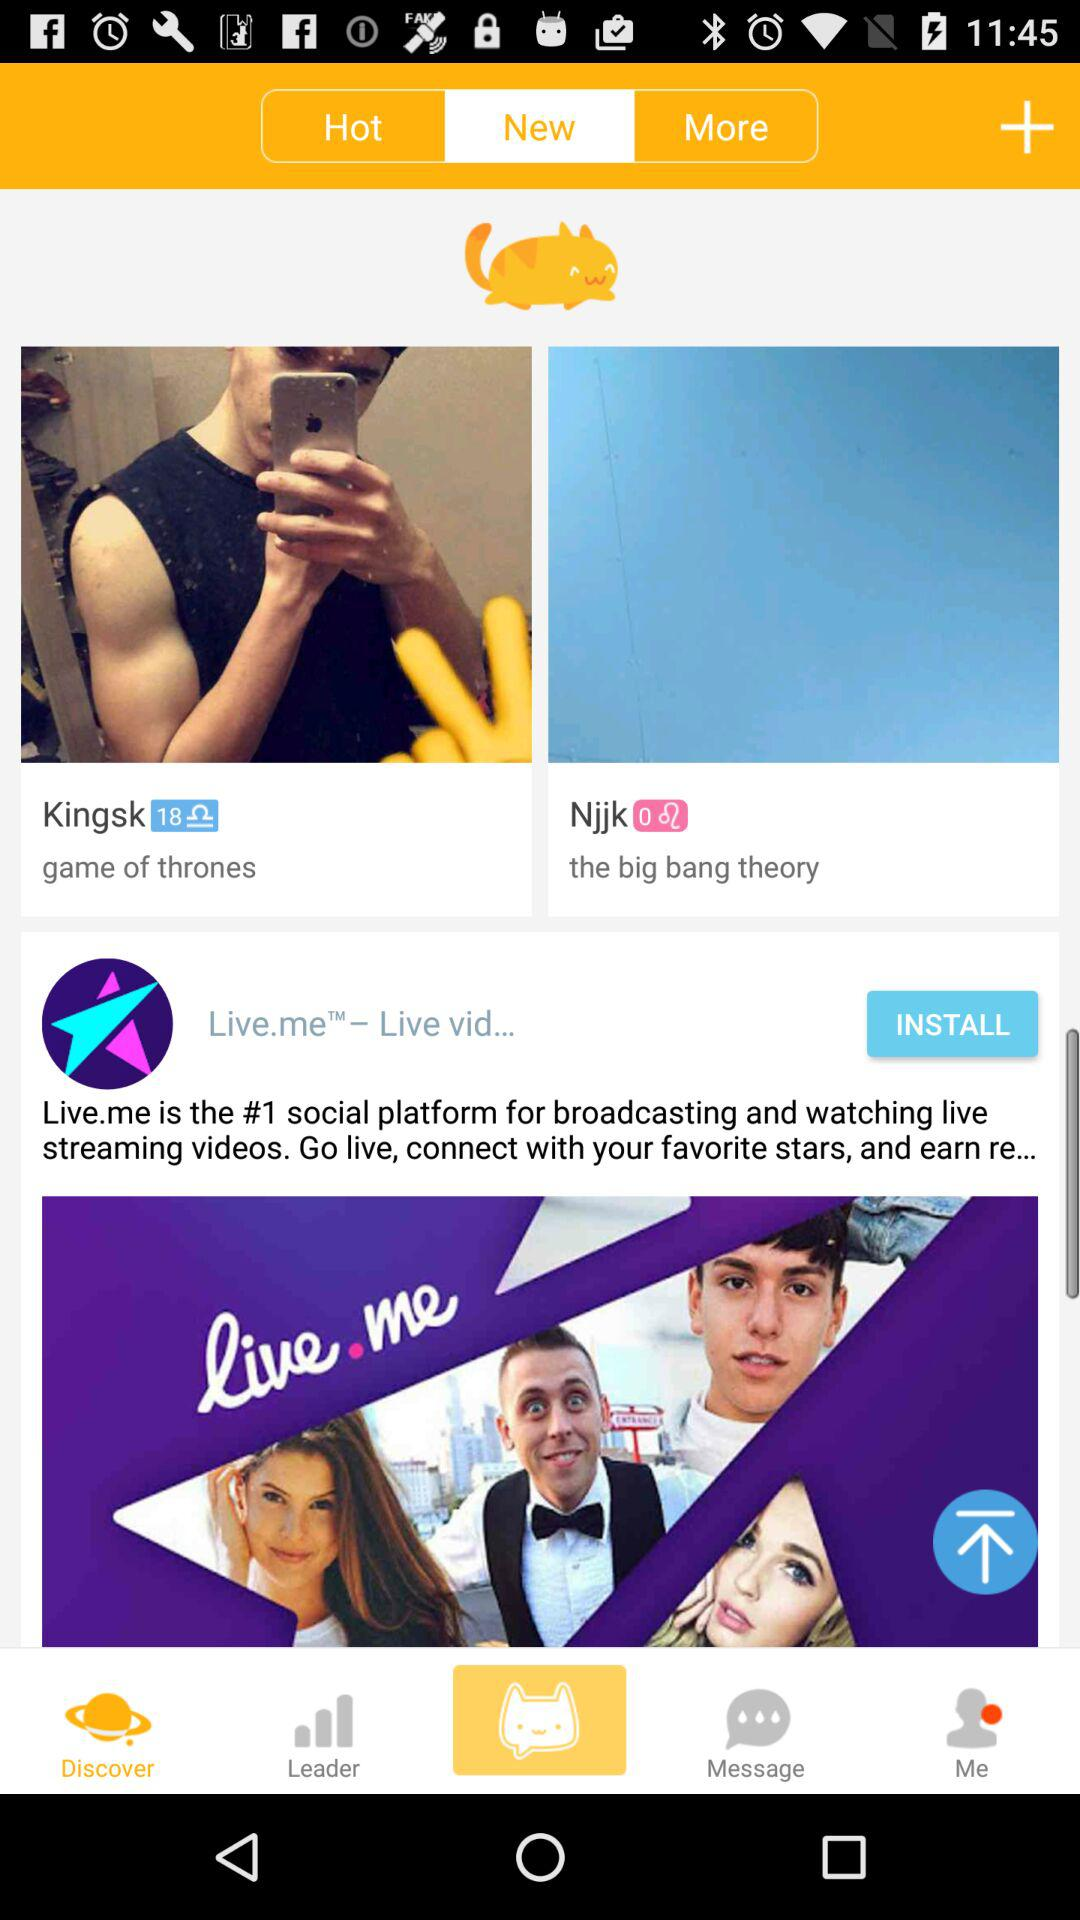What is the app name? The app name is "MeowChat". 